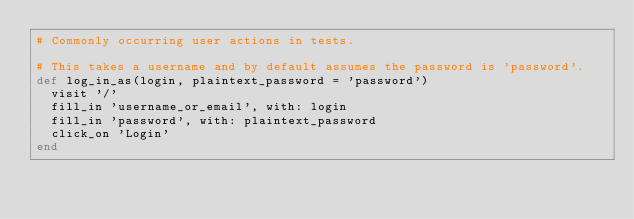<code> <loc_0><loc_0><loc_500><loc_500><_Ruby_># Commonly occurring user actions in tests.

# This takes a username and by default assumes the password is 'password'.
def log_in_as(login, plaintext_password = 'password')
  visit '/'
  fill_in 'username_or_email', with: login
  fill_in 'password', with: plaintext_password
  click_on 'Login'
end
</code> 